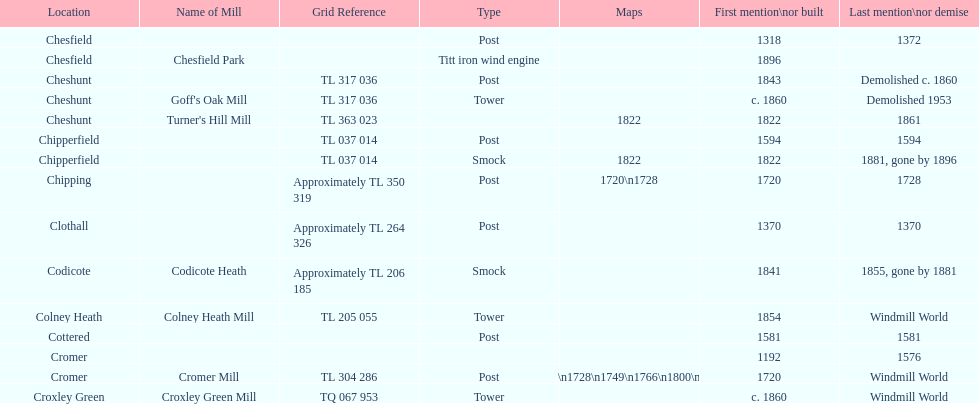Can you parse all the data within this table? {'header': ['Location', 'Name of Mill', 'Grid Reference', 'Type', 'Maps', 'First mention\\nor built', 'Last mention\\nor demise'], 'rows': [['Chesfield', '', '', 'Post', '', '1318', '1372'], ['Chesfield', 'Chesfield Park', '', 'Titt iron wind engine', '', '1896', ''], ['Cheshunt', '', 'TL 317 036', 'Post', '', '1843', 'Demolished c. 1860'], ['Cheshunt', "Goff's Oak Mill", 'TL 317 036', 'Tower', '', 'c. 1860', 'Demolished 1953'], ['Cheshunt', "Turner's Hill Mill", 'TL 363 023', '', '1822', '1822', '1861'], ['Chipperfield', '', 'TL 037 014', 'Post', '', '1594', '1594'], ['Chipperfield', '', 'TL 037 014', 'Smock', '1822', '1822', '1881, gone by 1896'], ['Chipping', '', 'Approximately TL 350 319', 'Post', '1720\\n1728', '1720', '1728'], ['Clothall', '', 'Approximately TL 264 326', 'Post', '', '1370', '1370'], ['Codicote', 'Codicote Heath', 'Approximately TL 206 185', 'Smock', '', '1841', '1855, gone by 1881'], ['Colney Heath', 'Colney Heath Mill', 'TL 205 055', 'Tower', '', '1854', 'Windmill World'], ['Cottered', '', '', 'Post', '', '1581', '1581'], ['Cromer', '', '', '', '', '1192', '1576'], ['Cromer', 'Cromer Mill', 'TL 304 286', 'Post', '1720\\n1728\\n1749\\n1766\\n1800\\n1822', '1720', 'Windmill World'], ['Croxley Green', 'Croxley Green Mill', 'TQ 067 953', 'Tower', '', 'c. 1860', 'Windmill World']]} What is the number of mills first mentioned or built in the 1800s? 8. 